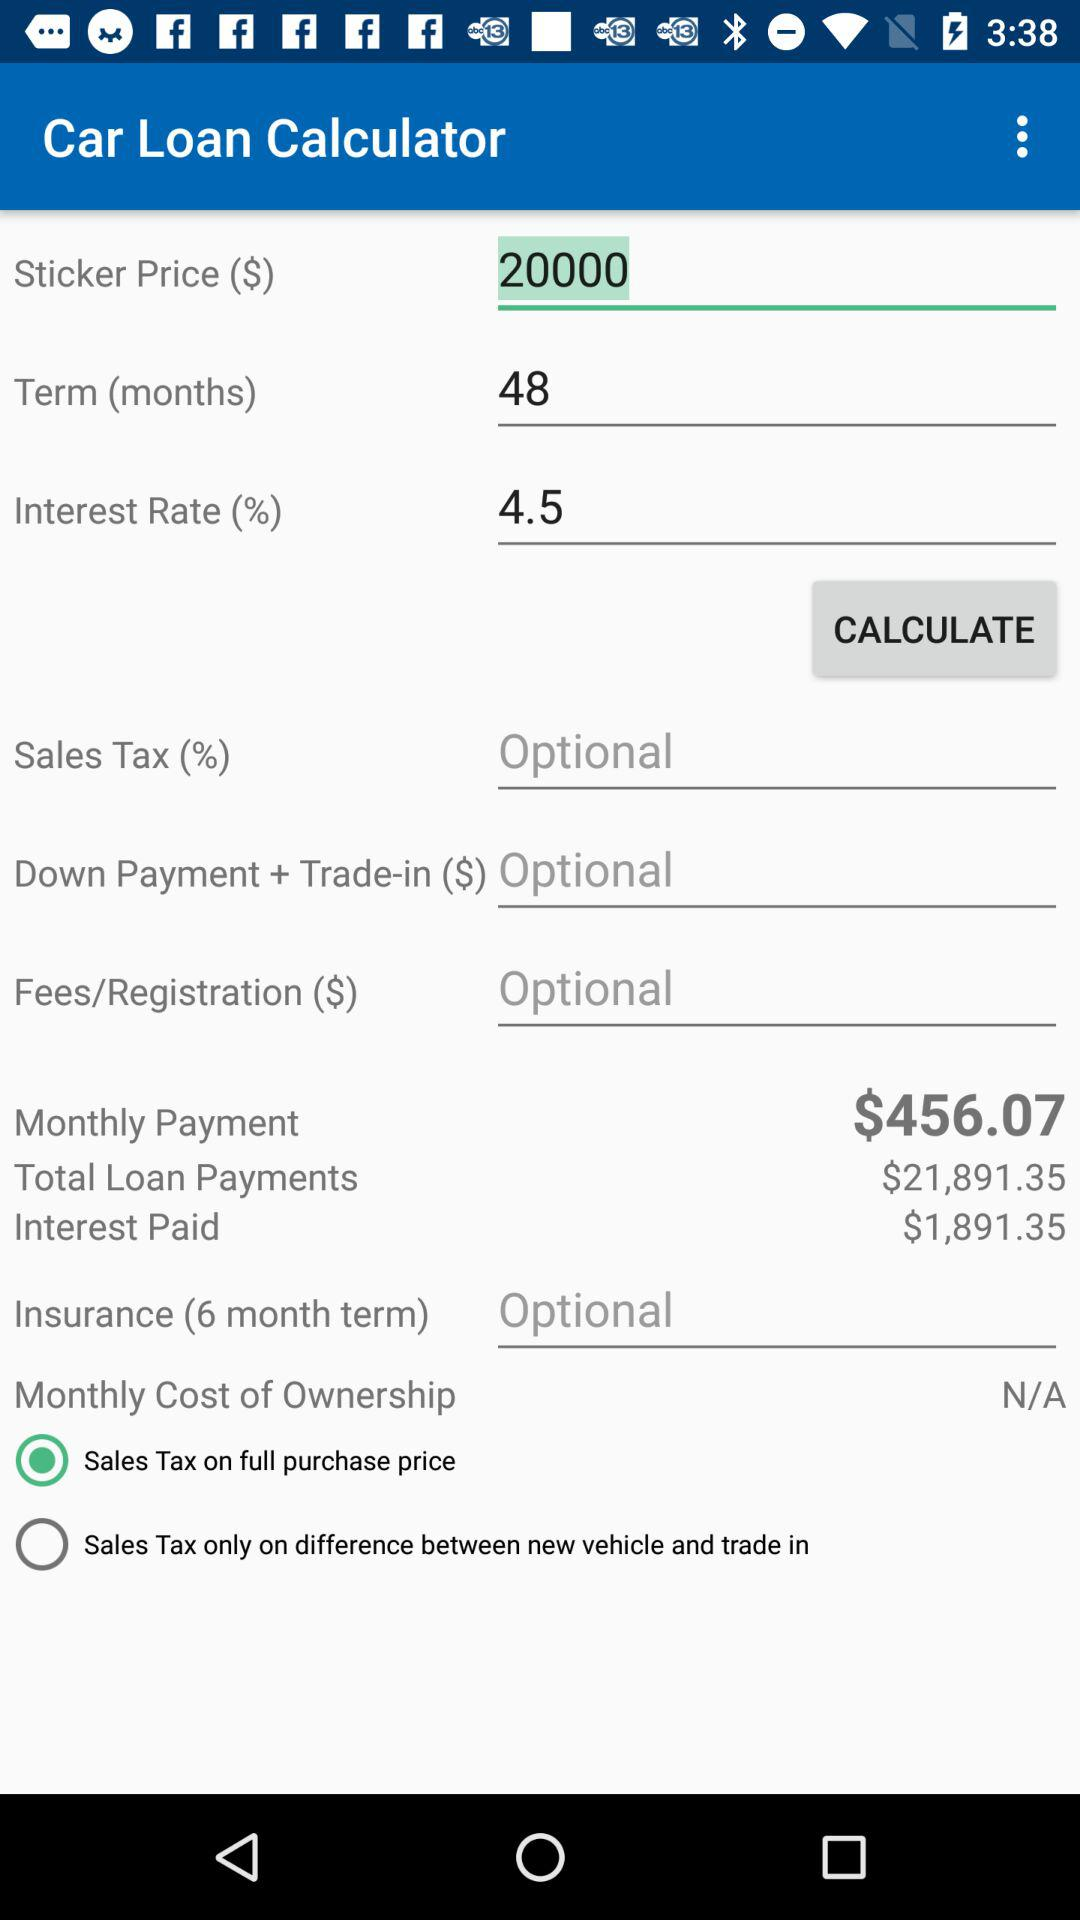What is the monthly payment? The monthly payment is $456.07. 